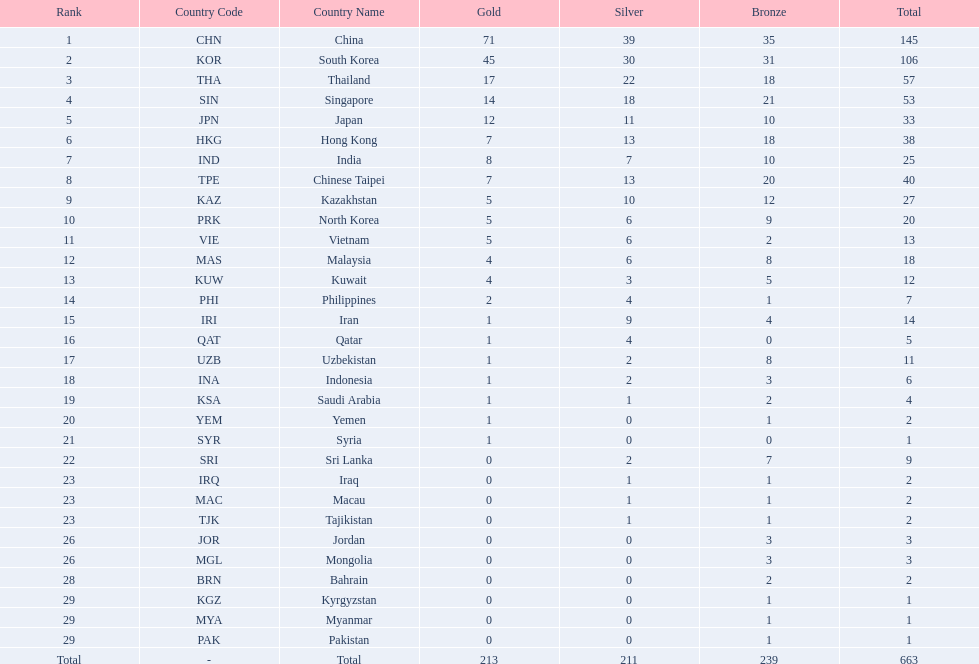What is the difference between the total amount of medals won by qatar and indonesia? 1. 